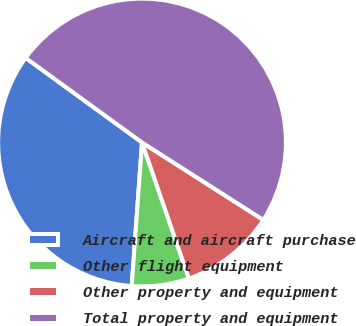<chart> <loc_0><loc_0><loc_500><loc_500><pie_chart><fcel>Aircraft and aircraft purchase<fcel>Other flight equipment<fcel>Other property and equipment<fcel>Total property and equipment<nl><fcel>33.86%<fcel>6.42%<fcel>10.68%<fcel>49.04%<nl></chart> 